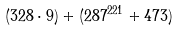Convert formula to latex. <formula><loc_0><loc_0><loc_500><loc_500>( 3 2 8 \cdot 9 ) + ( 2 8 7 ^ { 2 2 1 } + 4 7 3 )</formula> 